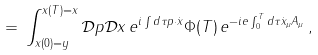<formula> <loc_0><loc_0><loc_500><loc_500>= \, \int _ { x ( 0 ) = y } ^ { x ( T ) = x } { \mathcal { D } } p { \mathcal { D } } x \, e ^ { i \int d \tau p \cdot { \dot { x } } } \Phi ( T ) \, e ^ { - i e \int _ { 0 } ^ { T } d \tau { \dot { x } } _ { \mu } A _ { \mu } } \, ,</formula> 